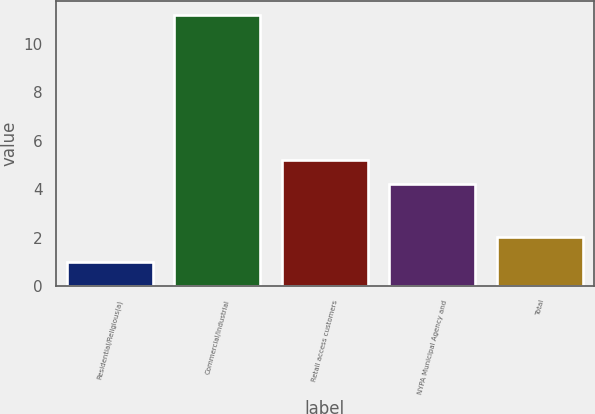Convert chart to OTSL. <chart><loc_0><loc_0><loc_500><loc_500><bar_chart><fcel>Residential/Religious(a)<fcel>Commercial/Industrial<fcel>Retail access customers<fcel>NYPA Municipal Agency and<fcel>Total<nl><fcel>1<fcel>11.2<fcel>5.22<fcel>4.2<fcel>2.02<nl></chart> 